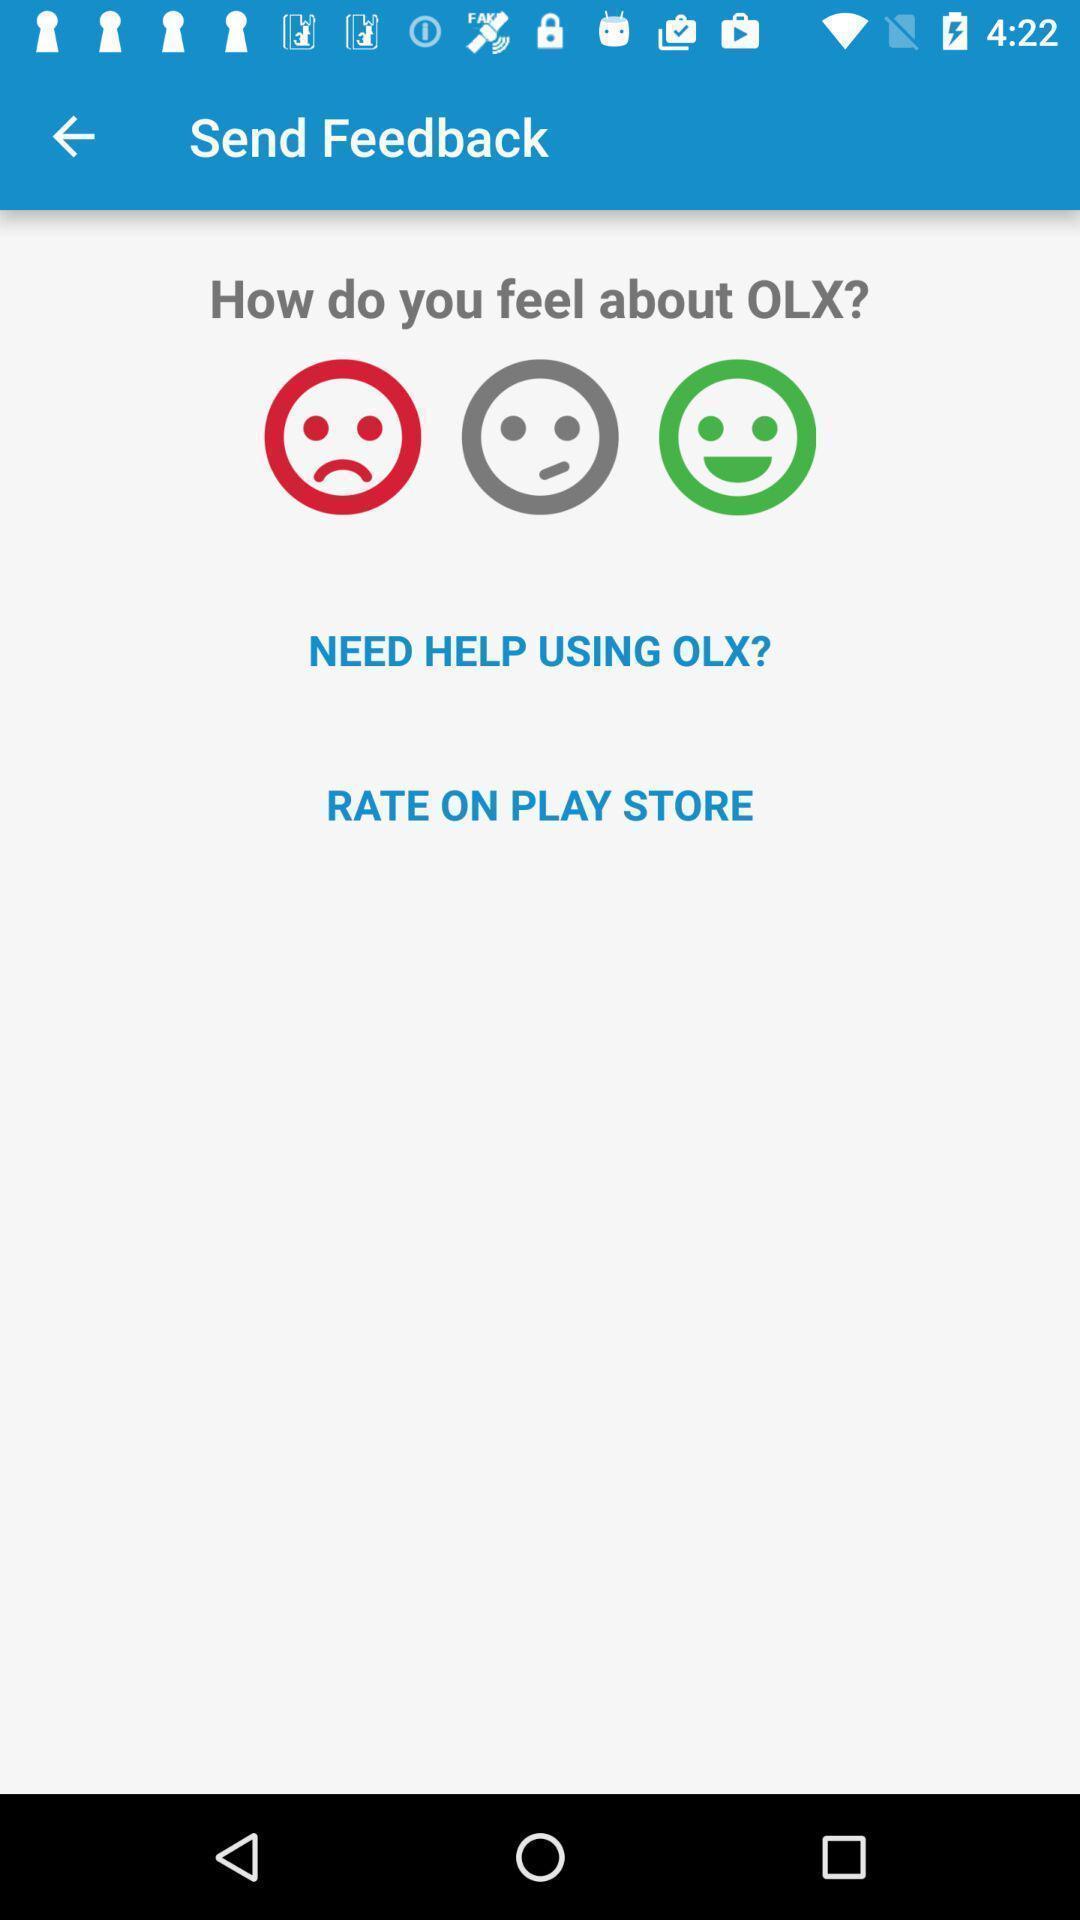Explain the elements present in this screenshot. Screen displaying rating page. 